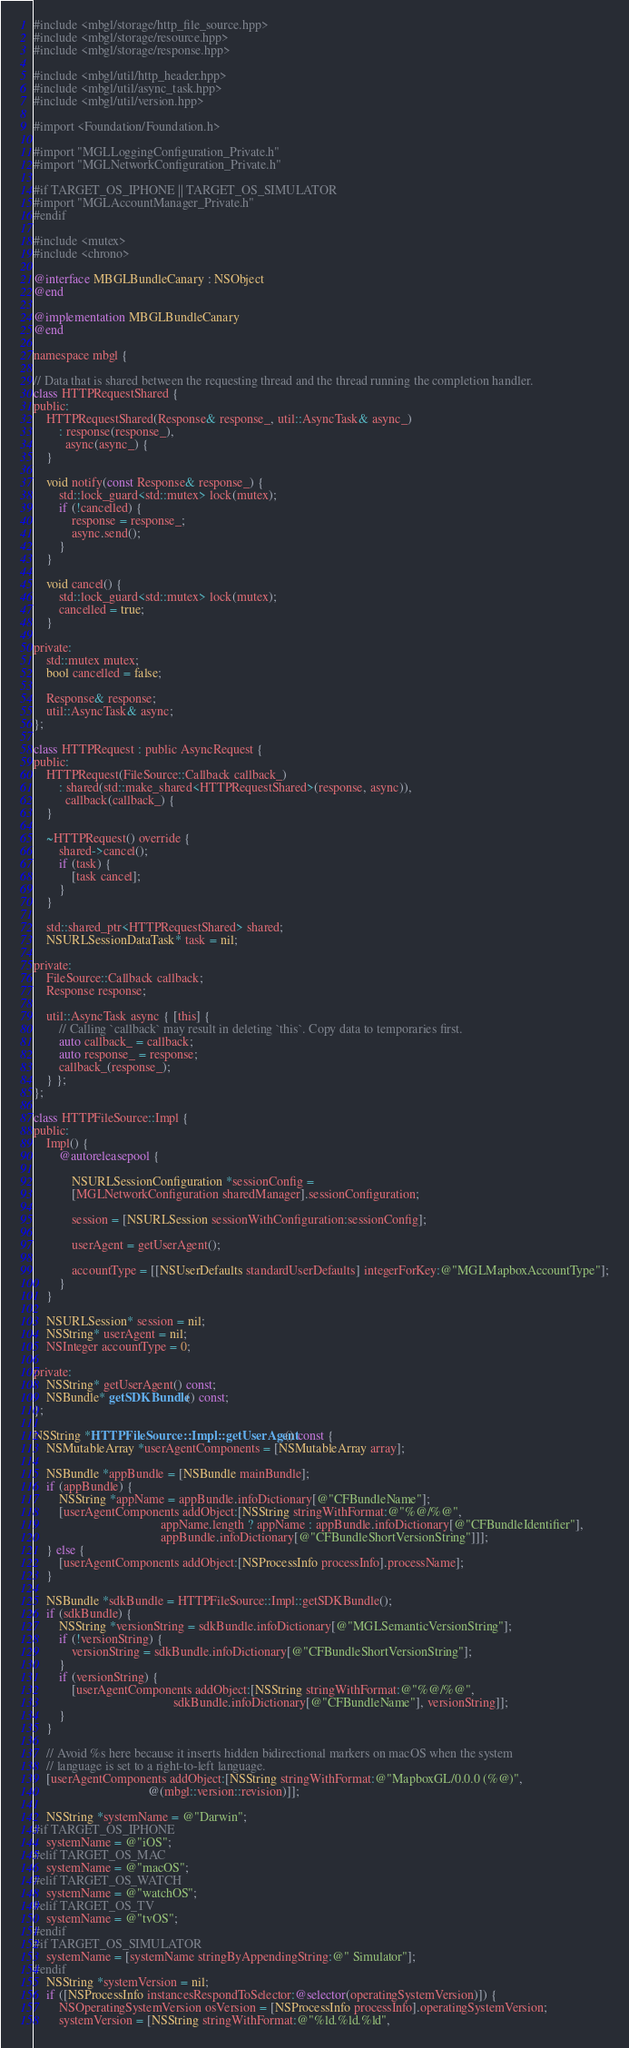Convert code to text. <code><loc_0><loc_0><loc_500><loc_500><_ObjectiveC_>#include <mbgl/storage/http_file_source.hpp>
#include <mbgl/storage/resource.hpp>
#include <mbgl/storage/response.hpp>

#include <mbgl/util/http_header.hpp>
#include <mbgl/util/async_task.hpp>
#include <mbgl/util/version.hpp>

#import <Foundation/Foundation.h>

#import "MGLLoggingConfiguration_Private.h"
#import "MGLNetworkConfiguration_Private.h"

#if TARGET_OS_IPHONE || TARGET_OS_SIMULATOR
#import "MGLAccountManager_Private.h"
#endif

#include <mutex>
#include <chrono>

@interface MBGLBundleCanary : NSObject
@end

@implementation MBGLBundleCanary
@end

namespace mbgl {

// Data that is shared between the requesting thread and the thread running the completion handler.
class HTTPRequestShared {
public:
    HTTPRequestShared(Response& response_, util::AsyncTask& async_)
        : response(response_),
          async(async_) {
    }

    void notify(const Response& response_) {
        std::lock_guard<std::mutex> lock(mutex);
        if (!cancelled) {
            response = response_;
            async.send();
        }
    }

    void cancel() {
        std::lock_guard<std::mutex> lock(mutex);
        cancelled = true;
    }

private:
    std::mutex mutex;
    bool cancelled = false;

    Response& response;
    util::AsyncTask& async;
};

class HTTPRequest : public AsyncRequest {
public:
    HTTPRequest(FileSource::Callback callback_)
        : shared(std::make_shared<HTTPRequestShared>(response, async)),
          callback(callback_) {
    }

    ~HTTPRequest() override {
        shared->cancel();
        if (task) {
            [task cancel];
        }
    }

    std::shared_ptr<HTTPRequestShared> shared;
    NSURLSessionDataTask* task = nil;

private:
    FileSource::Callback callback;
    Response response;

    util::AsyncTask async { [this] {
        // Calling `callback` may result in deleting `this`. Copy data to temporaries first.
        auto callback_ = callback;
        auto response_ = response;
        callback_(response_);
    } };
};

class HTTPFileSource::Impl {
public:
    Impl() {
        @autoreleasepool {

            NSURLSessionConfiguration *sessionConfig =
            [MGLNetworkConfiguration sharedManager].sessionConfiguration;
            
            session = [NSURLSession sessionWithConfiguration:sessionConfig];

            userAgent = getUserAgent();

            accountType = [[NSUserDefaults standardUserDefaults] integerForKey:@"MGLMapboxAccountType"];
        }
    }

    NSURLSession* session = nil;
    NSString* userAgent = nil;
    NSInteger accountType = 0;

private:
    NSString* getUserAgent() const;
    NSBundle* getSDKBundle() const;
};

NSString *HTTPFileSource::Impl::getUserAgent() const {
    NSMutableArray *userAgentComponents = [NSMutableArray array];

    NSBundle *appBundle = [NSBundle mainBundle];
    if (appBundle) {
        NSString *appName = appBundle.infoDictionary[@"CFBundleName"];
        [userAgentComponents addObject:[NSString stringWithFormat:@"%@/%@",
                                        appName.length ? appName : appBundle.infoDictionary[@"CFBundleIdentifier"],
                                        appBundle.infoDictionary[@"CFBundleShortVersionString"]]];
    } else {
        [userAgentComponents addObject:[NSProcessInfo processInfo].processName];
    }

    NSBundle *sdkBundle = HTTPFileSource::Impl::getSDKBundle();
    if (sdkBundle) {
        NSString *versionString = sdkBundle.infoDictionary[@"MGLSemanticVersionString"];
        if (!versionString) {
            versionString = sdkBundle.infoDictionary[@"CFBundleShortVersionString"];
        }
        if (versionString) {
            [userAgentComponents addObject:[NSString stringWithFormat:@"%@/%@",
                                            sdkBundle.infoDictionary[@"CFBundleName"], versionString]];
        }
    }

    // Avoid %s here because it inserts hidden bidirectional markers on macOS when the system
    // language is set to a right-to-left language.
    [userAgentComponents addObject:[NSString stringWithFormat:@"MapboxGL/0.0.0 (%@)",
                                    @(mbgl::version::revision)]];

    NSString *systemName = @"Darwin";
#if TARGET_OS_IPHONE
    systemName = @"iOS";
#elif TARGET_OS_MAC
    systemName = @"macOS";
#elif TARGET_OS_WATCH
    systemName = @"watchOS";
#elif TARGET_OS_TV
    systemName = @"tvOS";
#endif
#if TARGET_OS_SIMULATOR
    systemName = [systemName stringByAppendingString:@" Simulator"];
#endif
    NSString *systemVersion = nil;
    if ([NSProcessInfo instancesRespondToSelector:@selector(operatingSystemVersion)]) {
        NSOperatingSystemVersion osVersion = [NSProcessInfo processInfo].operatingSystemVersion;
        systemVersion = [NSString stringWithFormat:@"%ld.%ld.%ld",</code> 